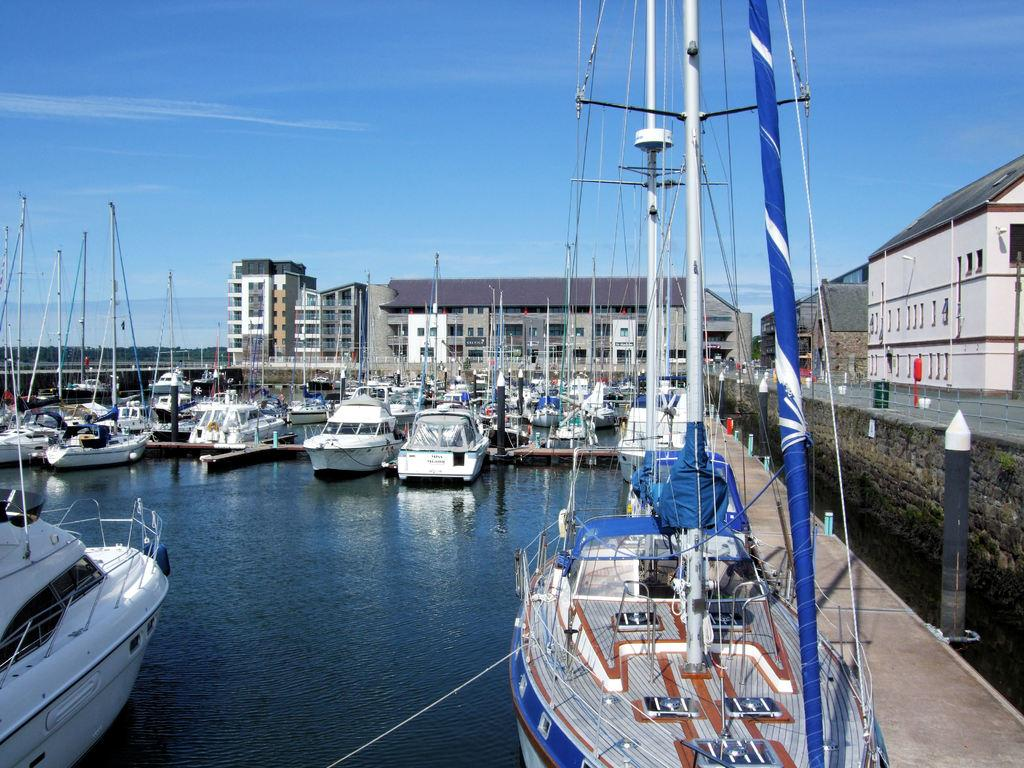What type of vehicles can be seen in the image? There are ships in the image. Where are the ships located? The ships are on the water. What can be seen in the background of the image? There are buildings in the background of the image. What is on the right side of the image? There is a wall on the right side of the image. How does the image perform addition? The image does not perform addition; it is a visual representation of ships, water, buildings, and a wall. 